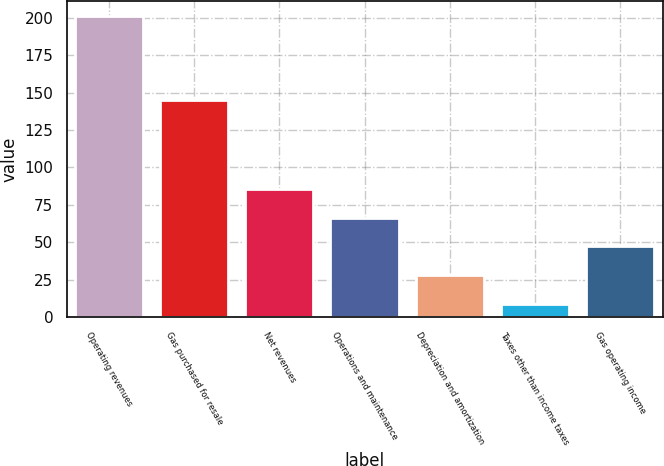Convert chart. <chart><loc_0><loc_0><loc_500><loc_500><bar_chart><fcel>Operating revenues<fcel>Gas purchased for resale<fcel>Net revenues<fcel>Operations and maintenance<fcel>Depreciation and amortization<fcel>Taxes other than income taxes<fcel>Gas operating income<nl><fcel>201<fcel>145<fcel>85.8<fcel>66.6<fcel>28.2<fcel>9<fcel>47.4<nl></chart> 